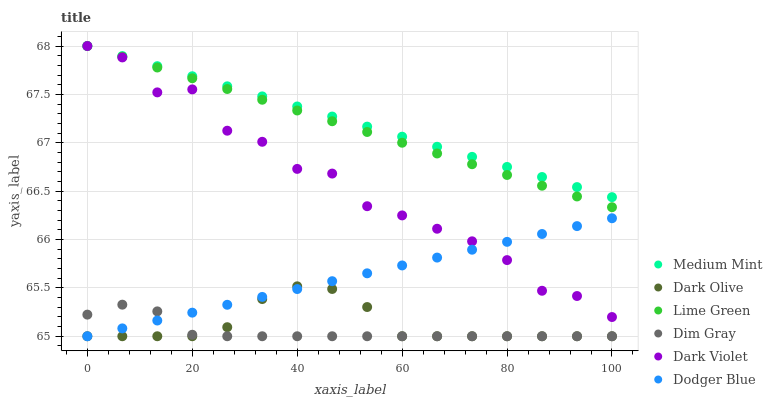Does Dim Gray have the minimum area under the curve?
Answer yes or no. Yes. Does Medium Mint have the maximum area under the curve?
Answer yes or no. Yes. Does Dark Olive have the minimum area under the curve?
Answer yes or no. No. Does Dark Olive have the maximum area under the curve?
Answer yes or no. No. Is Lime Green the smoothest?
Answer yes or no. Yes. Is Dark Violet the roughest?
Answer yes or no. Yes. Is Dim Gray the smoothest?
Answer yes or no. No. Is Dim Gray the roughest?
Answer yes or no. No. Does Dim Gray have the lowest value?
Answer yes or no. Yes. Does Dark Violet have the lowest value?
Answer yes or no. No. Does Lime Green have the highest value?
Answer yes or no. Yes. Does Dark Olive have the highest value?
Answer yes or no. No. Is Dodger Blue less than Medium Mint?
Answer yes or no. Yes. Is Dark Violet greater than Dark Olive?
Answer yes or no. Yes. Does Dodger Blue intersect Dim Gray?
Answer yes or no. Yes. Is Dodger Blue less than Dim Gray?
Answer yes or no. No. Is Dodger Blue greater than Dim Gray?
Answer yes or no. No. Does Dodger Blue intersect Medium Mint?
Answer yes or no. No. 